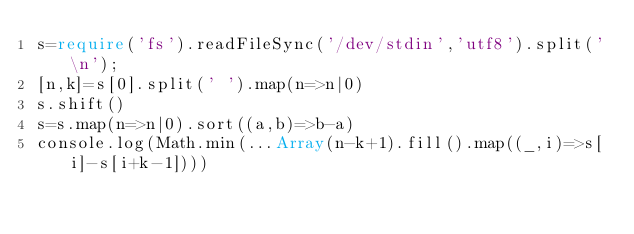Convert code to text. <code><loc_0><loc_0><loc_500><loc_500><_TypeScript_>s=require('fs').readFileSync('/dev/stdin','utf8').split('\n');
[n,k]=s[0].split(' ').map(n=>n|0)
s.shift()
s=s.map(n=>n|0).sort((a,b)=>b-a)
console.log(Math.min(...Array(n-k+1).fill().map((_,i)=>s[i]-s[i+k-1])))</code> 